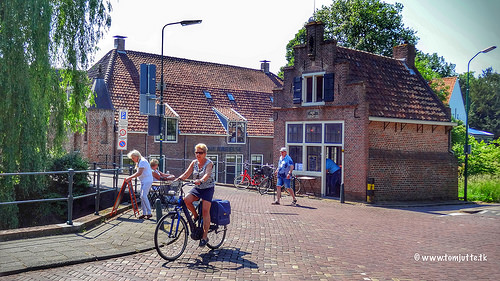<image>
Is the bicycle to the left of the woman? Yes. From this viewpoint, the bicycle is positioned to the left side relative to the woman. 